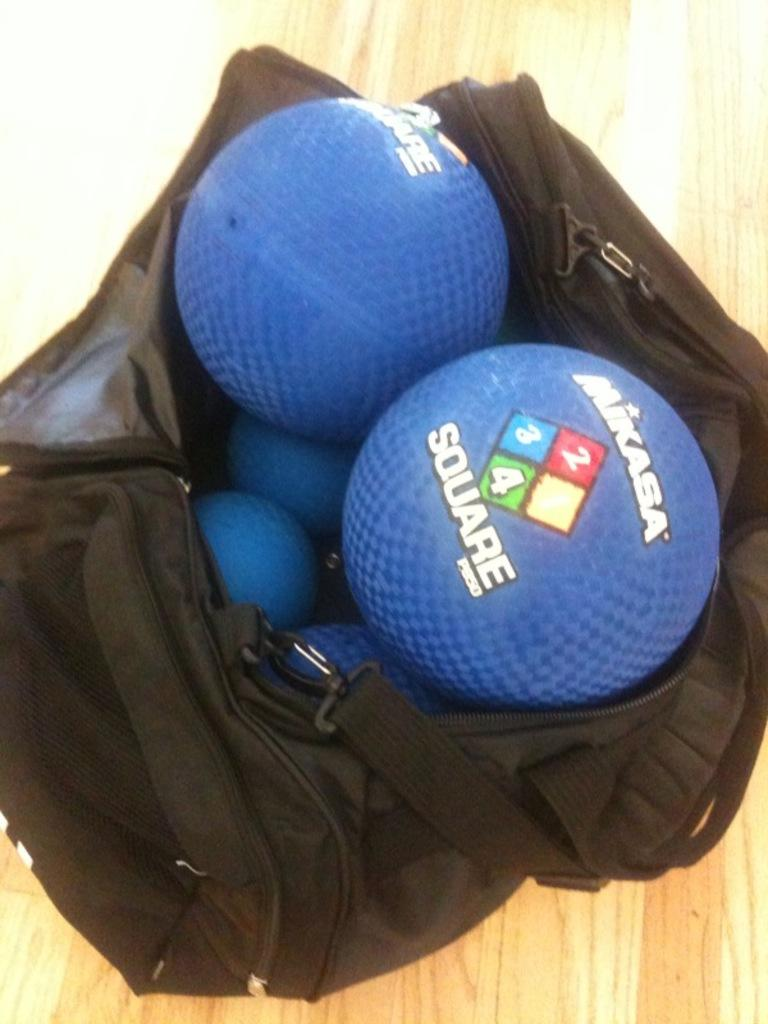What is the color of the bag in the image? The bag in the image is black. What is inside the bag? The bag is filled with blue color balls. What type of line is visible on the bag in the image? There is no line visible on the bag in the image. What action are the blue color balls performing in the image? The blue color balls are not performing any action in the image; they are stationary inside the bag. 